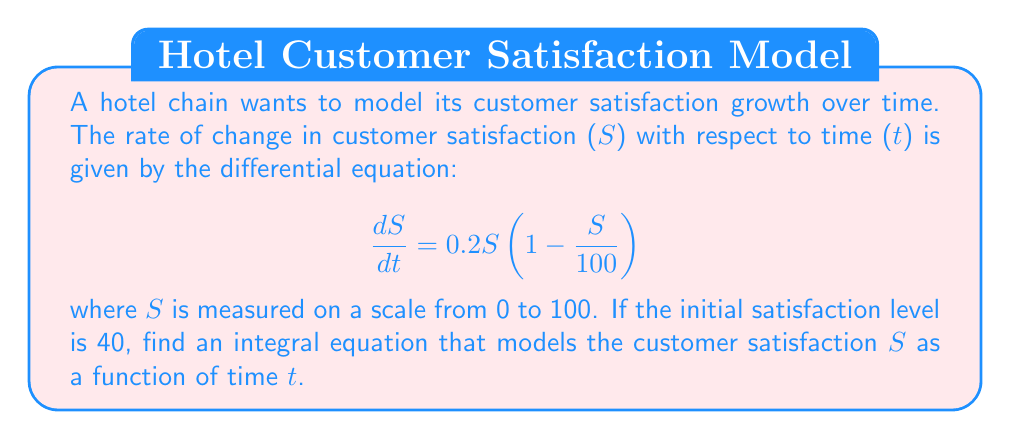Solve this math problem. 1. We start with the given differential equation:
   $$\frac{dS}{dt} = 0.2S(1 - \frac{S}{100})$$

2. To solve this, we need to separate the variables:
   $$\frac{dS}{S(1 - \frac{S}{100})} = 0.2dt$$

3. Integrate both sides:
   $$\int \frac{dS}{S(1 - \frac{S}{100})} = \int 0.2dt$$

4. The left-hand side can be integrated using partial fractions:
   $$\int (\frac{1}{S} + \frac{1}{100-S})dS = 0.2t + C$$

5. Evaluating the integral:
   $$\ln|S| - \ln|100-S| = 0.2t + C$$

6. Simplify:
   $$\ln|\frac{S}{100-S}| = 0.2t + C$$

7. Apply the exponential function to both sides:
   $$\frac{S}{100-S} = Ae^{0.2t}$$
   where $A = e^C$

8. Solve for S:
   $$S = \frac{100Ae^{0.2t}}{1 + Ae^{0.2t}}$$

9. Use the initial condition S(0) = 40 to find A:
   $$40 = \frac{100A}{1 + A}$$
   $$A = \frac{2}{3}$$

10. The final integral equation is:
    $$S = \frac{100(\frac{2}{3})e^{0.2t}}{1 + (\frac{2}{3})e^{0.2t}} = \frac{200e^{0.2t}}{3 + 2e^{0.2t}}$$
Answer: $$S = \frac{200e^{0.2t}}{3 + 2e^{0.2t}}$$ 